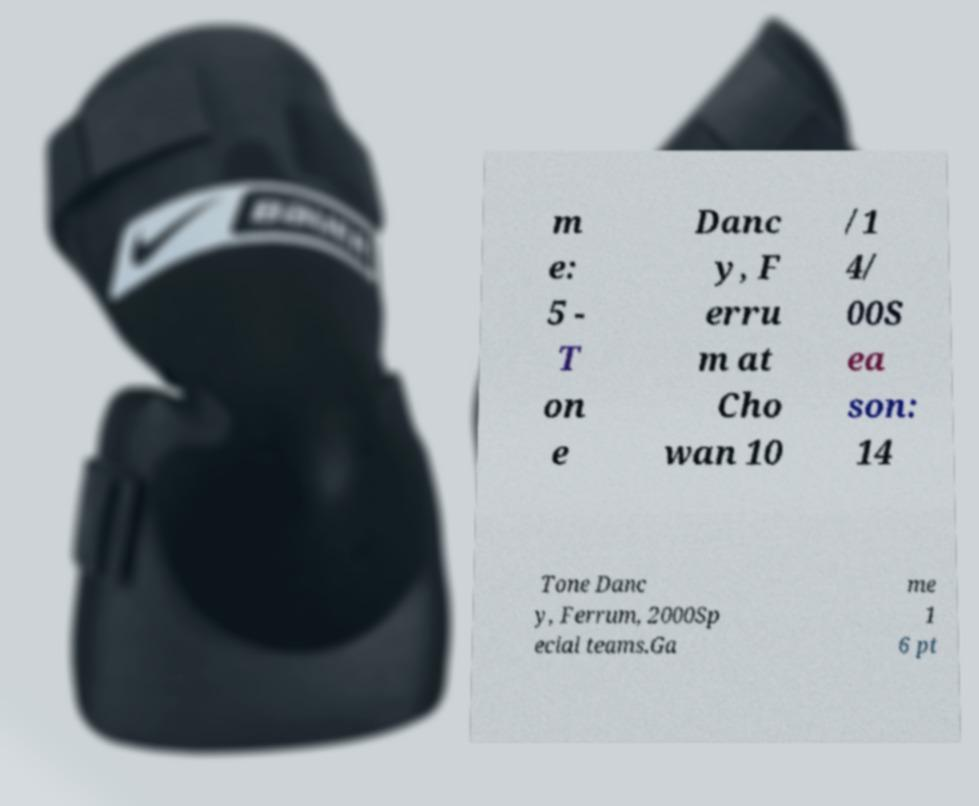For documentation purposes, I need the text within this image transcribed. Could you provide that? m e: 5 - T on e Danc y, F erru m at Cho wan 10 /1 4/ 00S ea son: 14 Tone Danc y, Ferrum, 2000Sp ecial teams.Ga me 1 6 pt 